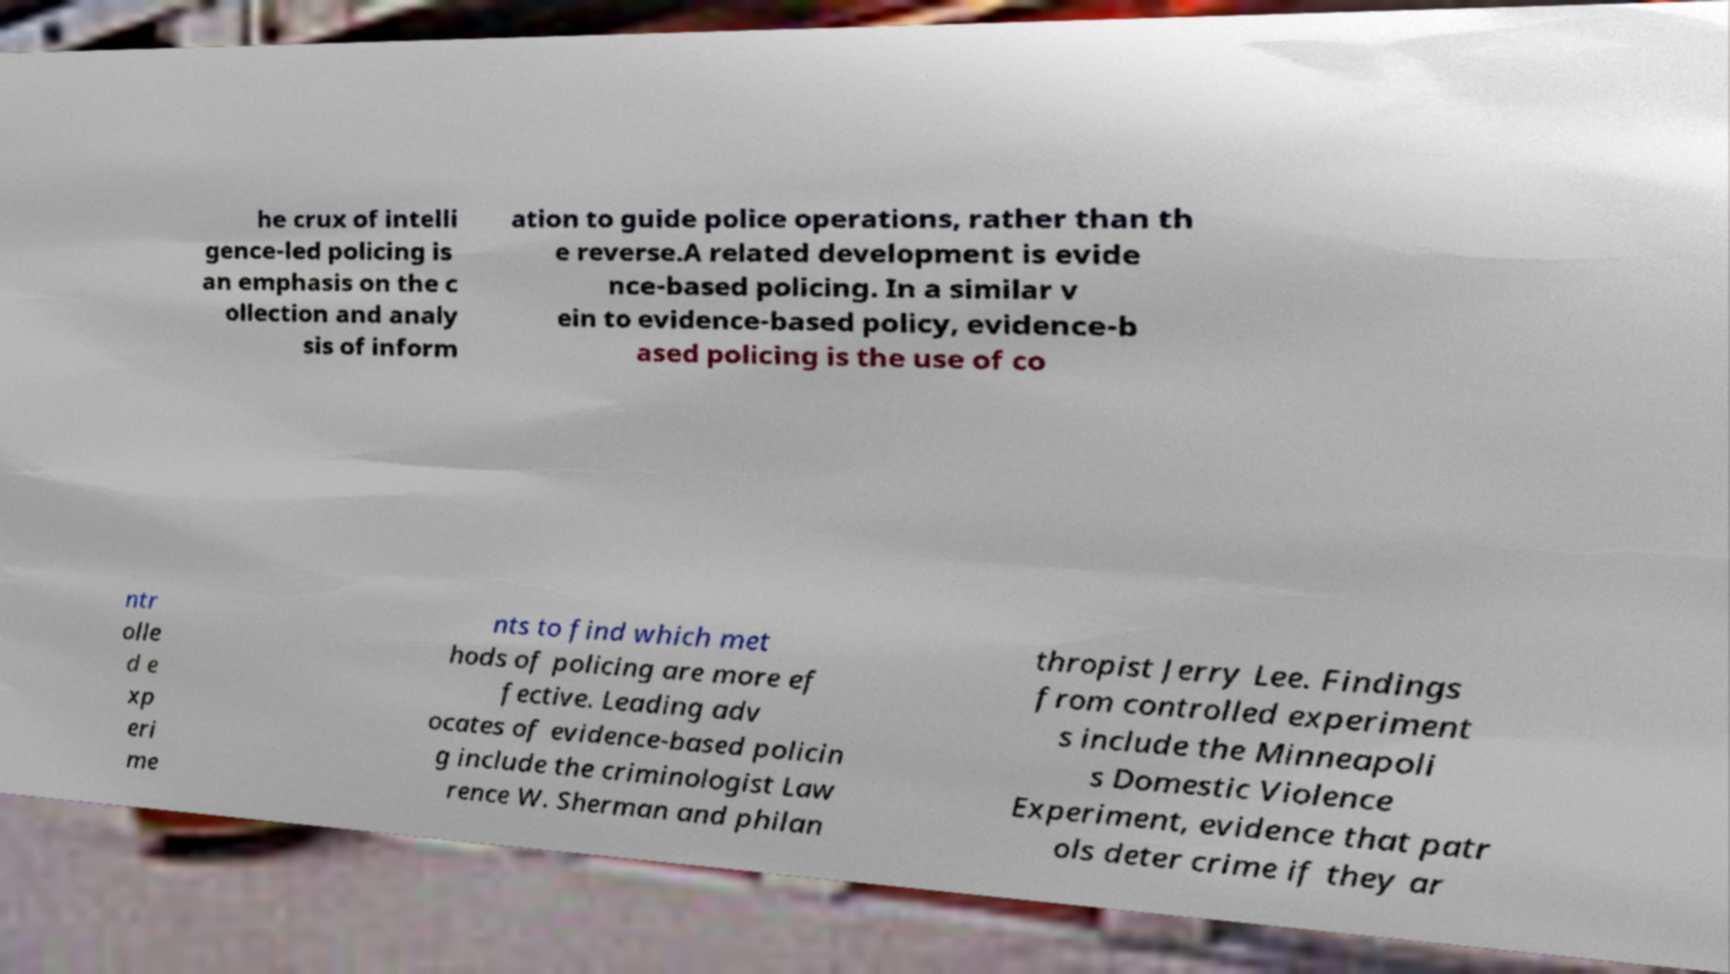Could you assist in decoding the text presented in this image and type it out clearly? he crux of intelli gence-led policing is an emphasis on the c ollection and analy sis of inform ation to guide police operations, rather than th e reverse.A related development is evide nce-based policing. In a similar v ein to evidence-based policy, evidence-b ased policing is the use of co ntr olle d e xp eri me nts to find which met hods of policing are more ef fective. Leading adv ocates of evidence-based policin g include the criminologist Law rence W. Sherman and philan thropist Jerry Lee. Findings from controlled experiment s include the Minneapoli s Domestic Violence Experiment, evidence that patr ols deter crime if they ar 